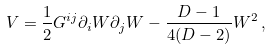Convert formula to latex. <formula><loc_0><loc_0><loc_500><loc_500>V = \frac { 1 } { 2 } G ^ { i j } \partial _ { i } W \partial _ { j } W - \frac { D - 1 } { 4 ( D - 2 ) } W ^ { 2 } \, ,</formula> 